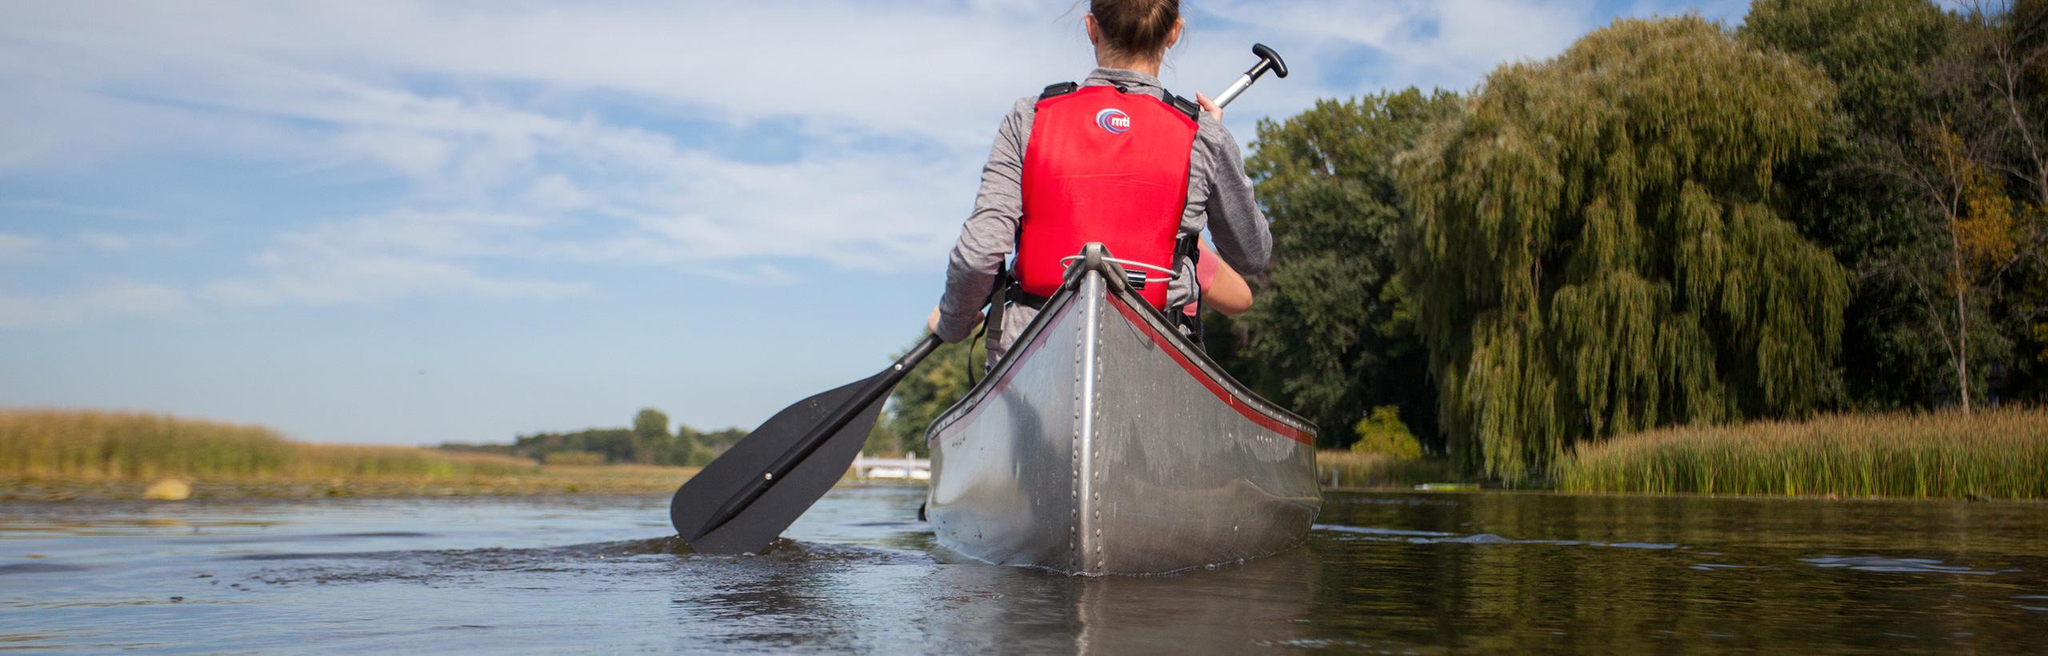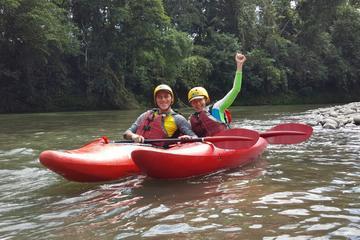The first image is the image on the left, the second image is the image on the right. Considering the images on both sides, is "One image shows only rowers in red kayaks." valid? Answer yes or no. Yes. 